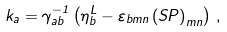<formula> <loc_0><loc_0><loc_500><loc_500>k _ { a } = \gamma ^ { - 1 } _ { a b } \left ( \eta ^ { L } _ { b } - \varepsilon _ { b m n } \left ( S P \right ) _ { m n } \right ) \, ,</formula> 